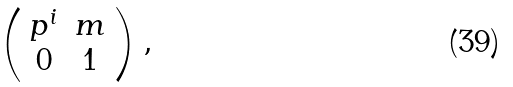<formula> <loc_0><loc_0><loc_500><loc_500>\left ( \begin{array} { c c } p ^ { i } & m \\ 0 & 1 \end{array} \right ) ,</formula> 